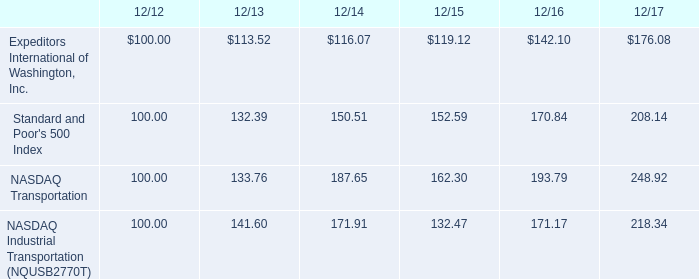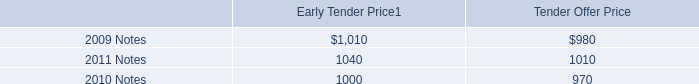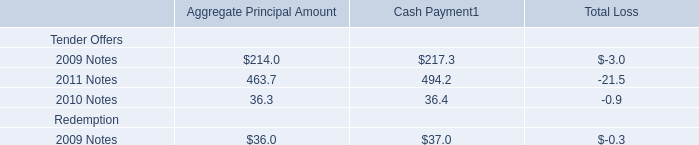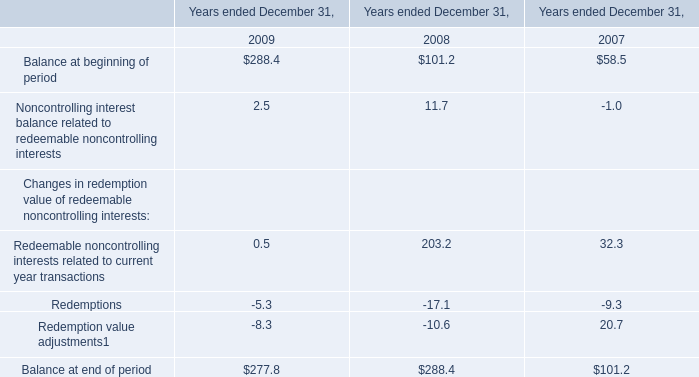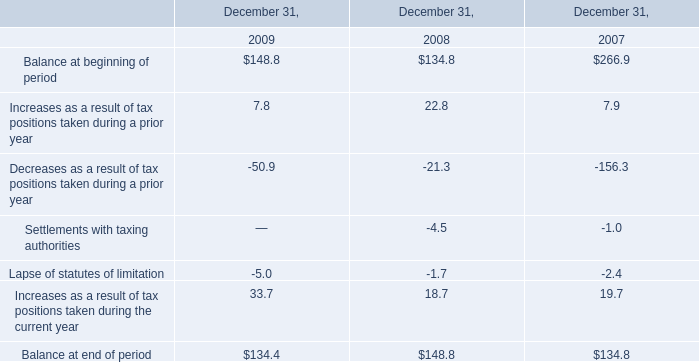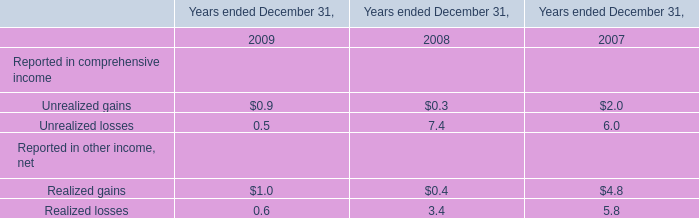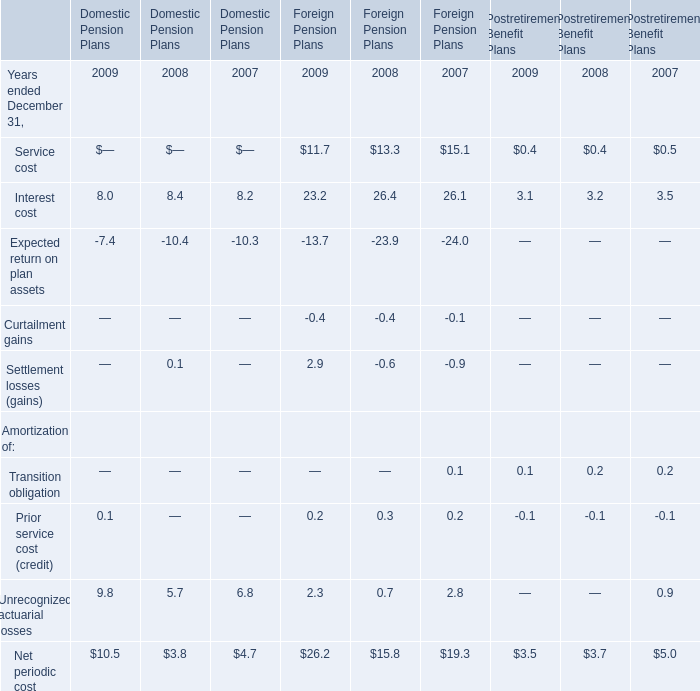What's the total amount of the Reported in comprehensive income in the years where Unrealized gains greater than 0? 
Computations: (((((0.9 + 0.3) + 2.0) + 0.5) + 7.4) + 6.0)
Answer: 17.1. 